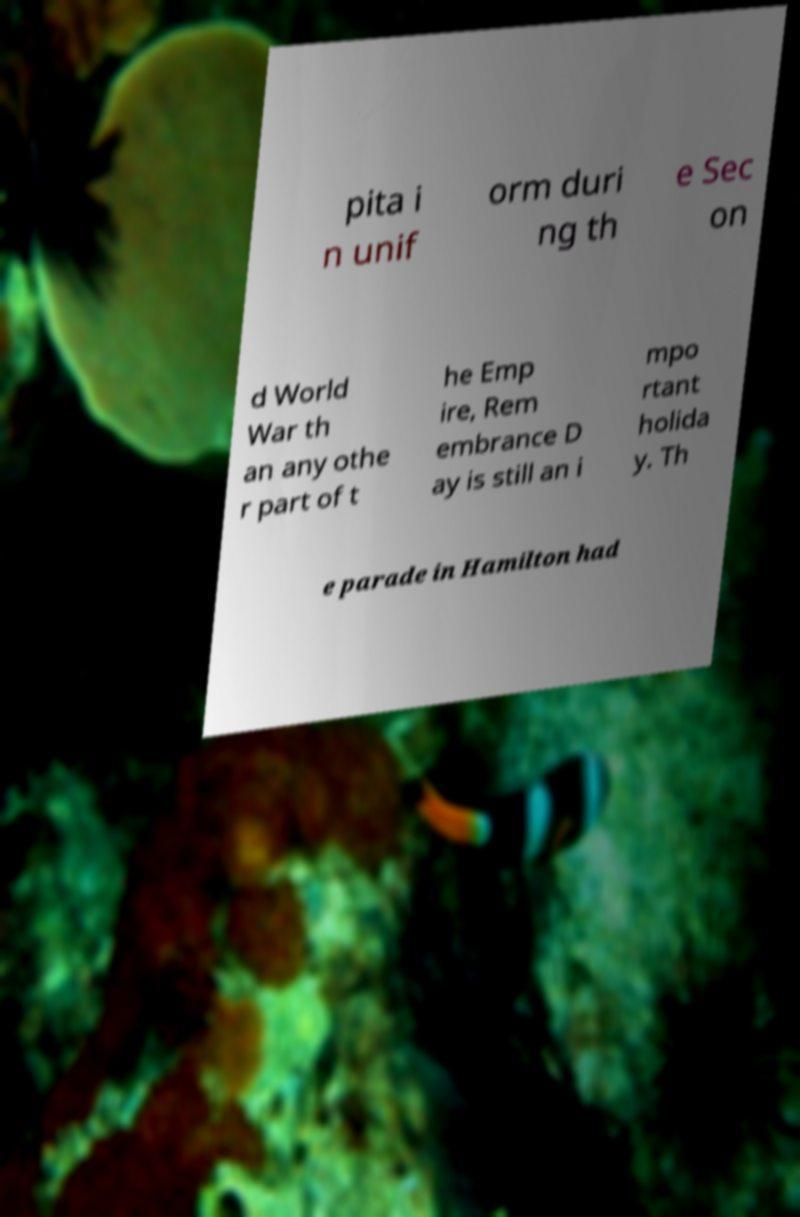What messages or text are displayed in this image? I need them in a readable, typed format. pita i n unif orm duri ng th e Sec on d World War th an any othe r part of t he Emp ire, Rem embrance D ay is still an i mpo rtant holida y. Th e parade in Hamilton had 